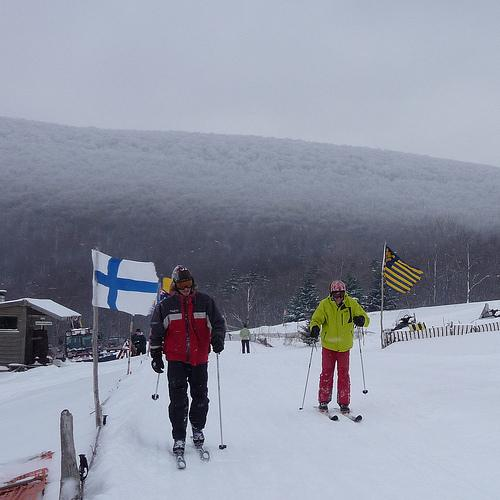Describe the weather condition in the image. The sky is overcast, suggesting that it might be cloudy or snowy weather. What are some safety gears worn by the two people skiing? Both skiers are wearing ski goggles and helmets on their heads as safety gear. Mention the types of trees present in the background. There are snow-covered pine trees in the background of the image. Write a description of the location where the two people are skiing. They are skiing on a snow-covered hill with pine trees and a mountain in the background, under an overcast sky. What are the prominent colors in the image, seen in clothing and flags? Prominent colors in the image are red, blue, white, yellow, and green in flags and clothing. State the type of footwear used by the people skiing. Both people are wearing snow skis on their feet while skiing down the hill. Please provide a detailed description of the flags present in the image. There are three flags: a white and blue flag, a yellow and blue flag, and an American flag on poles. Describe the appearance of the man on the left and the gear he's using. The man on the left is wearing red pants, a red and grey jacket, ski goggles, and skis on his feet while holding ski poles. Briefly describe what the woman on the right is wearing and her gear. The woman on the right is wearing a bright yellow jacket, red pants, goggles, and has snow skis on her feet and ski poles in her hands. Mention the primary activity happening in the image and the people involved. Two people are skiing down a snow-covered hill, wearing colorful jackets and ski goggles. 